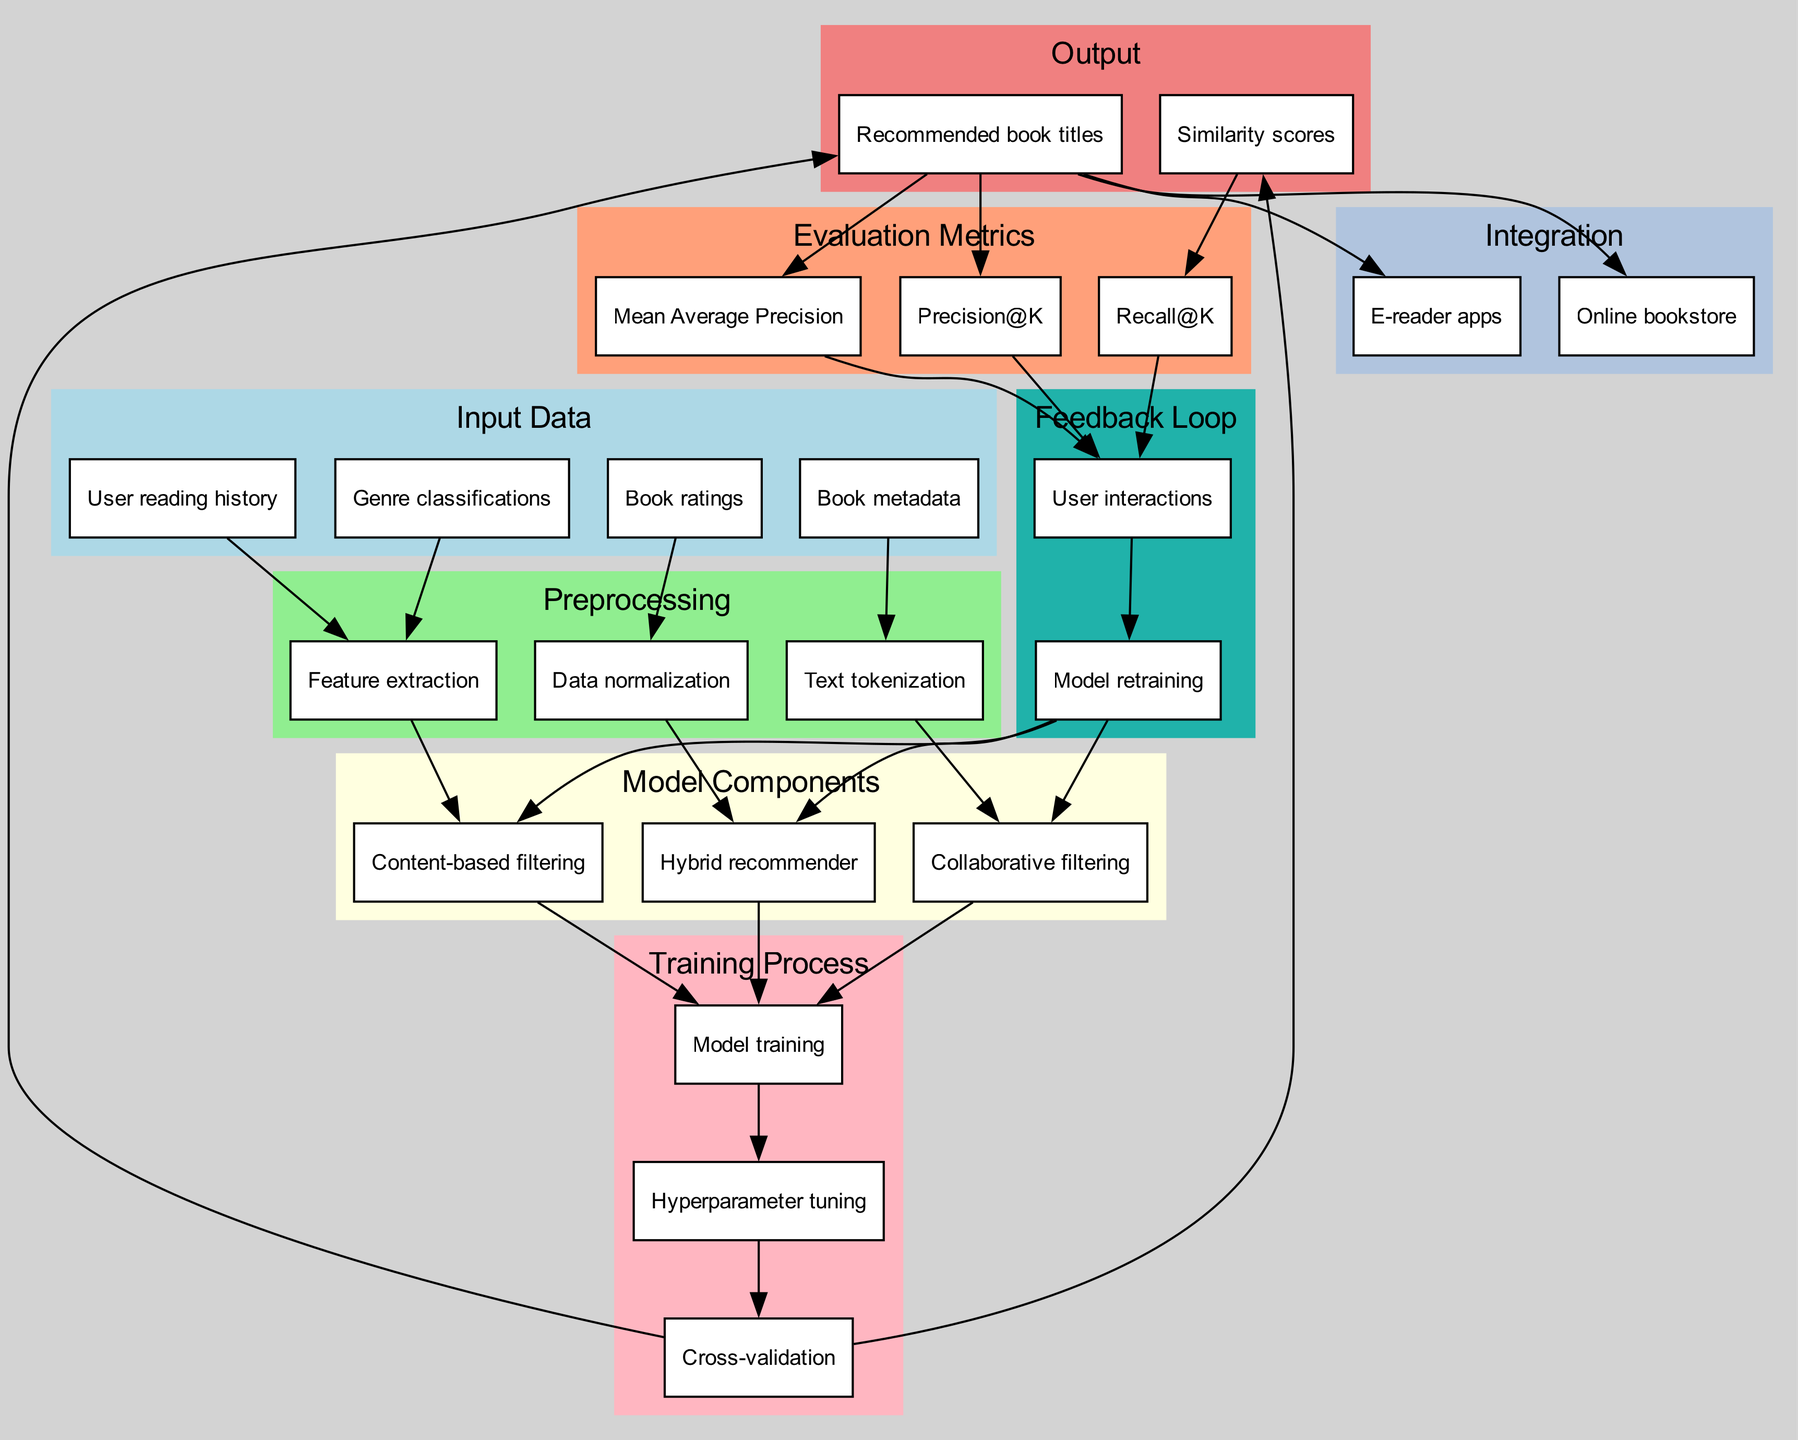What types of input data are required for the recommendation system? The diagram lists four types of input data: Book metadata, User reading history, Book ratings, and Genre classifications.
Answer: Book metadata, User reading history, Book ratings, Genre classifications How many model components are present in this diagram? There are three model components: Collaborative filtering, Content-based filtering, and Hybrid recommender, as indicated in the corresponding section of the diagram.
Answer: Three What outputs are generated from the training process? The output section notes that the training process results in Recommended book titles and Similarity scores, which flow from the Cross-validation node.
Answer: Recommended book titles, Similarity scores Which preprocessing step is related to both user reading history and book ratings? Feature extraction is the preprocessing step linked to User reading history and detailed in the diagram as receiving input from both book ratings and user reading history.
Answer: Feature extraction What evaluation metric is associated with user interactions? The diagram shows that Precision@K, Recall@K, and Mean Average Precision metrics are all connected to User interactions, indicating that all of them are evaluated based on user engagement.
Answer: Precision@K, Recall@K, Mean Average Precision Which node leads to model retraining in the feedback loop? User interactions lead to model retraining in the feedback loop, indicating a cycle where user engagement informs improvements in the model.
Answer: User interactions How is hyperparameter tuning connected within the training process? Hyperparameter tuning follows model training and precedes cross-validation, indicating its role in fine-tuning the model to improve performance before the final evaluation stage.
Answer: Model training What type of integration is illustrated in the diagram? The integration section lists Online bookstore and E-reader apps, showing the platforms where recommended titles will be provided to users.
Answer: Online bookstore, E-reader apps What is the flow of data after cross-validation in the training process? After cross-validation, the flow leads to both Recommended book titles and Similarity scores as outputs, indicating the results of the training process.
Answer: Recommended book titles, Similarity scores 